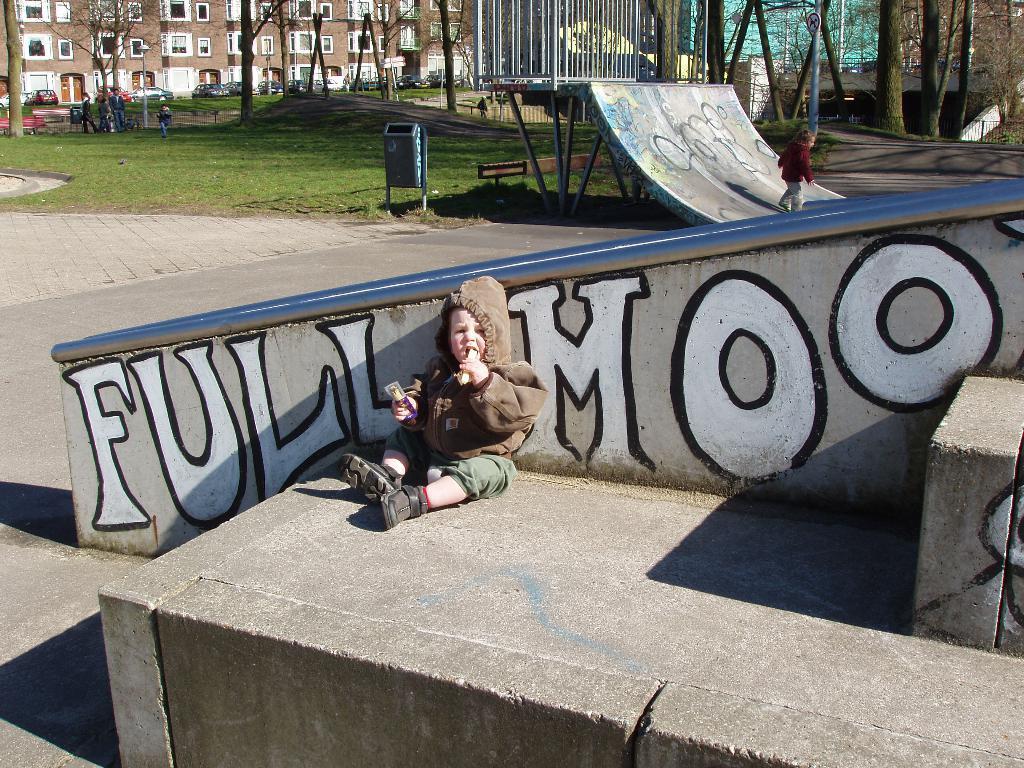Describe this image in one or two sentences. In the center of the image we can see kid sitting at the wall. In the background we can see kid is skating, dustbin, persons, grass, trees, building, road and sign board. 